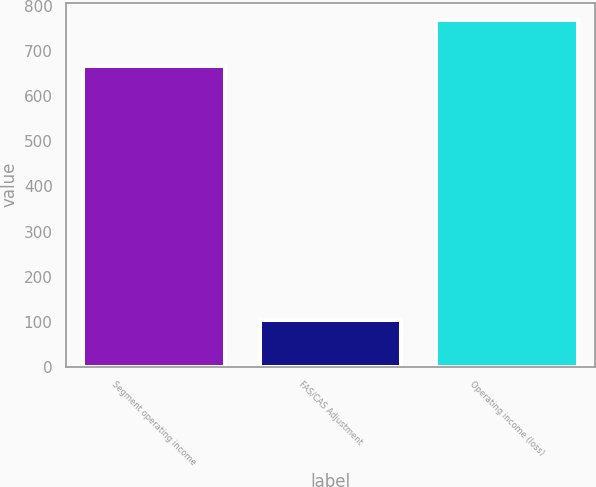Convert chart to OTSL. <chart><loc_0><loc_0><loc_500><loc_500><bar_chart><fcel>Segment operating income<fcel>FAS/CAS Adjustment<fcel>Operating income (loss)<nl><fcel>667<fcel>104<fcel>769<nl></chart> 